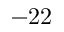Convert formula to latex. <formula><loc_0><loc_0><loc_500><loc_500>- 2 2</formula> 